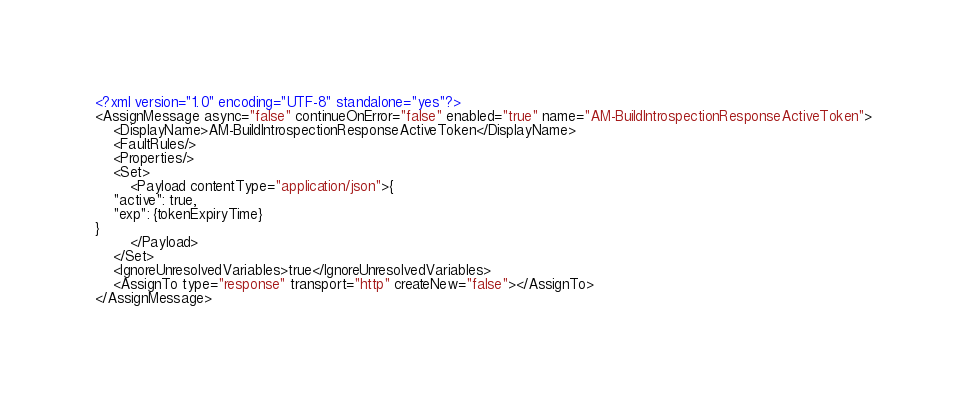<code> <loc_0><loc_0><loc_500><loc_500><_XML_><?xml version="1.0" encoding="UTF-8" standalone="yes"?>
<AssignMessage async="false" continueOnError="false" enabled="true" name="AM-BuildIntrospectionResponseActiveToken">
    <DisplayName>AM-BuildIntrospectionResponseActiveToken</DisplayName>
    <FaultRules/>
    <Properties/>
    <Set>
        <Payload contentType="application/json">{
    "active": true,
    "exp": {tokenExpiryTime}
}
        </Payload>
    </Set>
    <IgnoreUnresolvedVariables>true</IgnoreUnresolvedVariables>
    <AssignTo type="response" transport="http" createNew="false"></AssignTo>
</AssignMessage>
</code> 